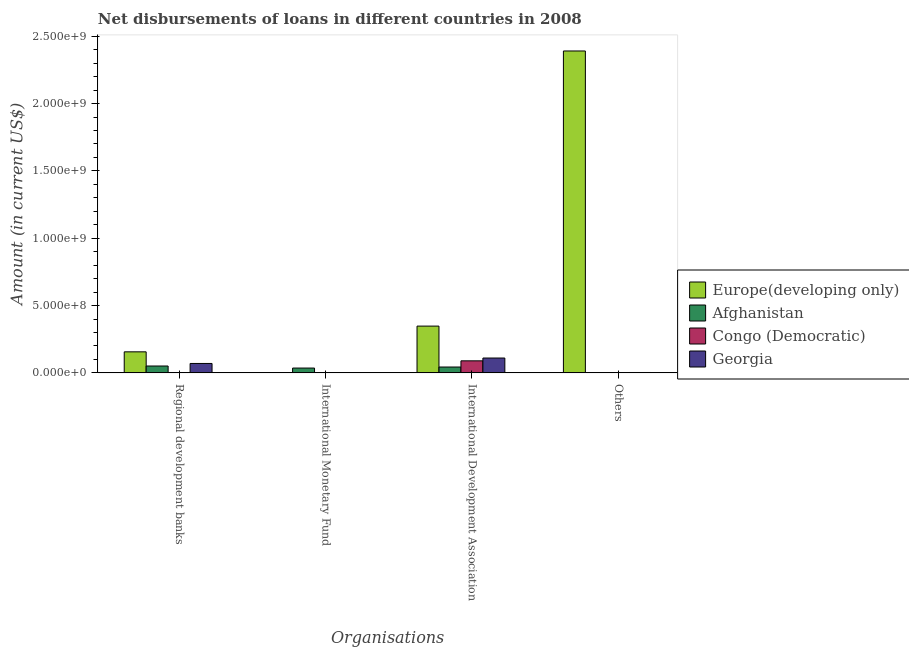How many different coloured bars are there?
Offer a terse response. 4. How many bars are there on the 3rd tick from the left?
Offer a very short reply. 4. What is the label of the 1st group of bars from the left?
Keep it short and to the point. Regional development banks. What is the amount of loan disimbursed by regional development banks in Congo (Democratic)?
Your answer should be very brief. 1.18e+06. Across all countries, what is the maximum amount of loan disimbursed by other organisations?
Keep it short and to the point. 2.39e+09. Across all countries, what is the minimum amount of loan disimbursed by international development association?
Give a very brief answer. 4.34e+07. In which country was the amount of loan disimbursed by international development association maximum?
Make the answer very short. Europe(developing only). What is the total amount of loan disimbursed by international development association in the graph?
Provide a succinct answer. 5.90e+08. What is the difference between the amount of loan disimbursed by international development association in Europe(developing only) and that in Georgia?
Give a very brief answer. 2.37e+08. What is the difference between the amount of loan disimbursed by international development association in Europe(developing only) and the amount of loan disimbursed by international monetary fund in Afghanistan?
Your answer should be compact. 3.12e+08. What is the average amount of loan disimbursed by international monetary fund per country?
Offer a very short reply. 8.93e+06. What is the difference between the amount of loan disimbursed by other organisations and amount of loan disimbursed by regional development banks in Afghanistan?
Offer a terse response. -5.08e+07. In how many countries, is the amount of loan disimbursed by international development association greater than 1200000000 US$?
Your answer should be very brief. 0. What is the ratio of the amount of loan disimbursed by other organisations in Afghanistan to that in Georgia?
Your response must be concise. 0.05. Is the amount of loan disimbursed by international development association in Europe(developing only) less than that in Congo (Democratic)?
Your response must be concise. No. What is the difference between the highest and the second highest amount of loan disimbursed by other organisations?
Offer a terse response. 2.39e+09. What is the difference between the highest and the lowest amount of loan disimbursed by international monetary fund?
Provide a short and direct response. 3.57e+07. In how many countries, is the amount of loan disimbursed by regional development banks greater than the average amount of loan disimbursed by regional development banks taken over all countries?
Keep it short and to the point. 2. Is the sum of the amount of loan disimbursed by regional development banks in Georgia and Europe(developing only) greater than the maximum amount of loan disimbursed by other organisations across all countries?
Your answer should be very brief. No. Is it the case that in every country, the sum of the amount of loan disimbursed by regional development banks and amount of loan disimbursed by international monetary fund is greater than the amount of loan disimbursed by international development association?
Your response must be concise. No. What is the title of the graph?
Make the answer very short. Net disbursements of loans in different countries in 2008. Does "South Africa" appear as one of the legend labels in the graph?
Offer a very short reply. No. What is the label or title of the X-axis?
Keep it short and to the point. Organisations. What is the Amount (in current US$) of Europe(developing only) in Regional development banks?
Your answer should be compact. 1.56e+08. What is the Amount (in current US$) in Afghanistan in Regional development banks?
Provide a short and direct response. 5.09e+07. What is the Amount (in current US$) of Congo (Democratic) in Regional development banks?
Provide a succinct answer. 1.18e+06. What is the Amount (in current US$) in Georgia in Regional development banks?
Offer a very short reply. 6.99e+07. What is the Amount (in current US$) of Afghanistan in International Monetary Fund?
Provide a short and direct response. 3.57e+07. What is the Amount (in current US$) in Europe(developing only) in International Development Association?
Ensure brevity in your answer.  3.47e+08. What is the Amount (in current US$) of Afghanistan in International Development Association?
Your answer should be compact. 4.34e+07. What is the Amount (in current US$) in Congo (Democratic) in International Development Association?
Provide a succinct answer. 8.94e+07. What is the Amount (in current US$) in Georgia in International Development Association?
Offer a very short reply. 1.10e+08. What is the Amount (in current US$) of Europe(developing only) in Others?
Ensure brevity in your answer.  2.39e+09. What is the Amount (in current US$) of Afghanistan in Others?
Provide a succinct answer. 1.33e+05. What is the Amount (in current US$) in Georgia in Others?
Make the answer very short. 2.82e+06. Across all Organisations, what is the maximum Amount (in current US$) of Europe(developing only)?
Ensure brevity in your answer.  2.39e+09. Across all Organisations, what is the maximum Amount (in current US$) of Afghanistan?
Give a very brief answer. 5.09e+07. Across all Organisations, what is the maximum Amount (in current US$) of Congo (Democratic)?
Your answer should be compact. 8.94e+07. Across all Organisations, what is the maximum Amount (in current US$) of Georgia?
Your answer should be compact. 1.10e+08. Across all Organisations, what is the minimum Amount (in current US$) of Europe(developing only)?
Your answer should be very brief. 0. Across all Organisations, what is the minimum Amount (in current US$) of Afghanistan?
Make the answer very short. 1.33e+05. Across all Organisations, what is the minimum Amount (in current US$) of Georgia?
Make the answer very short. 0. What is the total Amount (in current US$) of Europe(developing only) in the graph?
Provide a succinct answer. 2.89e+09. What is the total Amount (in current US$) of Afghanistan in the graph?
Make the answer very short. 1.30e+08. What is the total Amount (in current US$) in Congo (Democratic) in the graph?
Keep it short and to the point. 9.06e+07. What is the total Amount (in current US$) of Georgia in the graph?
Offer a terse response. 1.83e+08. What is the difference between the Amount (in current US$) of Afghanistan in Regional development banks and that in International Monetary Fund?
Provide a short and direct response. 1.52e+07. What is the difference between the Amount (in current US$) in Europe(developing only) in Regional development banks and that in International Development Association?
Your answer should be very brief. -1.91e+08. What is the difference between the Amount (in current US$) in Afghanistan in Regional development banks and that in International Development Association?
Offer a very short reply. 7.51e+06. What is the difference between the Amount (in current US$) of Congo (Democratic) in Regional development banks and that in International Development Association?
Your answer should be very brief. -8.82e+07. What is the difference between the Amount (in current US$) of Georgia in Regional development banks and that in International Development Association?
Provide a short and direct response. -4.04e+07. What is the difference between the Amount (in current US$) of Europe(developing only) in Regional development banks and that in Others?
Your response must be concise. -2.23e+09. What is the difference between the Amount (in current US$) of Afghanistan in Regional development banks and that in Others?
Your answer should be compact. 5.08e+07. What is the difference between the Amount (in current US$) of Georgia in Regional development banks and that in Others?
Keep it short and to the point. 6.70e+07. What is the difference between the Amount (in current US$) in Afghanistan in International Monetary Fund and that in International Development Association?
Provide a short and direct response. -7.70e+06. What is the difference between the Amount (in current US$) of Afghanistan in International Monetary Fund and that in Others?
Ensure brevity in your answer.  3.56e+07. What is the difference between the Amount (in current US$) in Europe(developing only) in International Development Association and that in Others?
Make the answer very short. -2.04e+09. What is the difference between the Amount (in current US$) in Afghanistan in International Development Association and that in Others?
Offer a very short reply. 4.33e+07. What is the difference between the Amount (in current US$) of Georgia in International Development Association and that in Others?
Your response must be concise. 1.07e+08. What is the difference between the Amount (in current US$) of Europe(developing only) in Regional development banks and the Amount (in current US$) of Afghanistan in International Monetary Fund?
Your answer should be very brief. 1.20e+08. What is the difference between the Amount (in current US$) in Europe(developing only) in Regional development banks and the Amount (in current US$) in Afghanistan in International Development Association?
Make the answer very short. 1.13e+08. What is the difference between the Amount (in current US$) in Europe(developing only) in Regional development banks and the Amount (in current US$) in Congo (Democratic) in International Development Association?
Provide a short and direct response. 6.68e+07. What is the difference between the Amount (in current US$) of Europe(developing only) in Regional development banks and the Amount (in current US$) of Georgia in International Development Association?
Keep it short and to the point. 4.60e+07. What is the difference between the Amount (in current US$) in Afghanistan in Regional development banks and the Amount (in current US$) in Congo (Democratic) in International Development Association?
Your response must be concise. -3.85e+07. What is the difference between the Amount (in current US$) of Afghanistan in Regional development banks and the Amount (in current US$) of Georgia in International Development Association?
Your answer should be very brief. -5.93e+07. What is the difference between the Amount (in current US$) of Congo (Democratic) in Regional development banks and the Amount (in current US$) of Georgia in International Development Association?
Give a very brief answer. -1.09e+08. What is the difference between the Amount (in current US$) of Europe(developing only) in Regional development banks and the Amount (in current US$) of Afghanistan in Others?
Your answer should be very brief. 1.56e+08. What is the difference between the Amount (in current US$) of Europe(developing only) in Regional development banks and the Amount (in current US$) of Georgia in Others?
Your answer should be compact. 1.53e+08. What is the difference between the Amount (in current US$) in Afghanistan in Regional development banks and the Amount (in current US$) in Georgia in Others?
Ensure brevity in your answer.  4.81e+07. What is the difference between the Amount (in current US$) of Congo (Democratic) in Regional development banks and the Amount (in current US$) of Georgia in Others?
Provide a short and direct response. -1.64e+06. What is the difference between the Amount (in current US$) in Afghanistan in International Monetary Fund and the Amount (in current US$) in Congo (Democratic) in International Development Association?
Make the answer very short. -5.37e+07. What is the difference between the Amount (in current US$) in Afghanistan in International Monetary Fund and the Amount (in current US$) in Georgia in International Development Association?
Provide a succinct answer. -7.45e+07. What is the difference between the Amount (in current US$) in Afghanistan in International Monetary Fund and the Amount (in current US$) in Georgia in Others?
Offer a terse response. 3.29e+07. What is the difference between the Amount (in current US$) of Europe(developing only) in International Development Association and the Amount (in current US$) of Afghanistan in Others?
Provide a short and direct response. 3.47e+08. What is the difference between the Amount (in current US$) of Europe(developing only) in International Development Association and the Amount (in current US$) of Georgia in Others?
Your answer should be compact. 3.45e+08. What is the difference between the Amount (in current US$) of Afghanistan in International Development Association and the Amount (in current US$) of Georgia in Others?
Provide a succinct answer. 4.06e+07. What is the difference between the Amount (in current US$) of Congo (Democratic) in International Development Association and the Amount (in current US$) of Georgia in Others?
Provide a short and direct response. 8.66e+07. What is the average Amount (in current US$) in Europe(developing only) per Organisations?
Give a very brief answer. 7.24e+08. What is the average Amount (in current US$) in Afghanistan per Organisations?
Offer a very short reply. 3.26e+07. What is the average Amount (in current US$) in Congo (Democratic) per Organisations?
Make the answer very short. 2.26e+07. What is the average Amount (in current US$) in Georgia per Organisations?
Your answer should be compact. 4.57e+07. What is the difference between the Amount (in current US$) in Europe(developing only) and Amount (in current US$) in Afghanistan in Regional development banks?
Offer a very short reply. 1.05e+08. What is the difference between the Amount (in current US$) of Europe(developing only) and Amount (in current US$) of Congo (Democratic) in Regional development banks?
Your answer should be very brief. 1.55e+08. What is the difference between the Amount (in current US$) of Europe(developing only) and Amount (in current US$) of Georgia in Regional development banks?
Offer a very short reply. 8.64e+07. What is the difference between the Amount (in current US$) of Afghanistan and Amount (in current US$) of Congo (Democratic) in Regional development banks?
Provide a succinct answer. 4.98e+07. What is the difference between the Amount (in current US$) in Afghanistan and Amount (in current US$) in Georgia in Regional development banks?
Offer a very short reply. -1.89e+07. What is the difference between the Amount (in current US$) in Congo (Democratic) and Amount (in current US$) in Georgia in Regional development banks?
Provide a short and direct response. -6.87e+07. What is the difference between the Amount (in current US$) in Europe(developing only) and Amount (in current US$) in Afghanistan in International Development Association?
Make the answer very short. 3.04e+08. What is the difference between the Amount (in current US$) in Europe(developing only) and Amount (in current US$) in Congo (Democratic) in International Development Association?
Provide a short and direct response. 2.58e+08. What is the difference between the Amount (in current US$) of Europe(developing only) and Amount (in current US$) of Georgia in International Development Association?
Provide a succinct answer. 2.37e+08. What is the difference between the Amount (in current US$) of Afghanistan and Amount (in current US$) of Congo (Democratic) in International Development Association?
Offer a terse response. -4.60e+07. What is the difference between the Amount (in current US$) in Afghanistan and Amount (in current US$) in Georgia in International Development Association?
Offer a terse response. -6.68e+07. What is the difference between the Amount (in current US$) in Congo (Democratic) and Amount (in current US$) in Georgia in International Development Association?
Ensure brevity in your answer.  -2.08e+07. What is the difference between the Amount (in current US$) of Europe(developing only) and Amount (in current US$) of Afghanistan in Others?
Offer a very short reply. 2.39e+09. What is the difference between the Amount (in current US$) of Europe(developing only) and Amount (in current US$) of Georgia in Others?
Provide a short and direct response. 2.39e+09. What is the difference between the Amount (in current US$) in Afghanistan and Amount (in current US$) in Georgia in Others?
Offer a terse response. -2.69e+06. What is the ratio of the Amount (in current US$) of Afghanistan in Regional development banks to that in International Monetary Fund?
Ensure brevity in your answer.  1.43. What is the ratio of the Amount (in current US$) in Europe(developing only) in Regional development banks to that in International Development Association?
Make the answer very short. 0.45. What is the ratio of the Amount (in current US$) in Afghanistan in Regional development banks to that in International Development Association?
Your response must be concise. 1.17. What is the ratio of the Amount (in current US$) in Congo (Democratic) in Regional development banks to that in International Development Association?
Give a very brief answer. 0.01. What is the ratio of the Amount (in current US$) in Georgia in Regional development banks to that in International Development Association?
Keep it short and to the point. 0.63. What is the ratio of the Amount (in current US$) of Europe(developing only) in Regional development banks to that in Others?
Make the answer very short. 0.07. What is the ratio of the Amount (in current US$) of Afghanistan in Regional development banks to that in Others?
Give a very brief answer. 382.99. What is the ratio of the Amount (in current US$) of Georgia in Regional development banks to that in Others?
Give a very brief answer. 24.74. What is the ratio of the Amount (in current US$) in Afghanistan in International Monetary Fund to that in International Development Association?
Give a very brief answer. 0.82. What is the ratio of the Amount (in current US$) in Afghanistan in International Monetary Fund to that in Others?
Make the answer very short. 268.61. What is the ratio of the Amount (in current US$) of Europe(developing only) in International Development Association to that in Others?
Provide a short and direct response. 0.15. What is the ratio of the Amount (in current US$) of Afghanistan in International Development Association to that in Others?
Your answer should be very brief. 326.54. What is the ratio of the Amount (in current US$) in Georgia in International Development Association to that in Others?
Give a very brief answer. 39.03. What is the difference between the highest and the second highest Amount (in current US$) of Europe(developing only)?
Provide a short and direct response. 2.04e+09. What is the difference between the highest and the second highest Amount (in current US$) of Afghanistan?
Keep it short and to the point. 7.51e+06. What is the difference between the highest and the second highest Amount (in current US$) in Georgia?
Offer a very short reply. 4.04e+07. What is the difference between the highest and the lowest Amount (in current US$) in Europe(developing only)?
Keep it short and to the point. 2.39e+09. What is the difference between the highest and the lowest Amount (in current US$) in Afghanistan?
Offer a very short reply. 5.08e+07. What is the difference between the highest and the lowest Amount (in current US$) in Congo (Democratic)?
Ensure brevity in your answer.  8.94e+07. What is the difference between the highest and the lowest Amount (in current US$) in Georgia?
Offer a terse response. 1.10e+08. 